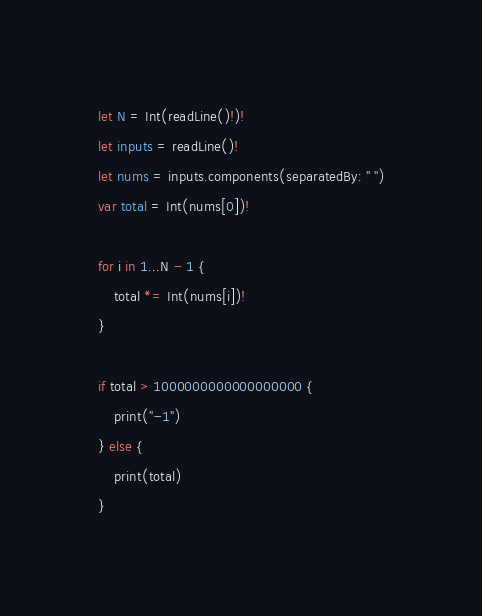<code> <loc_0><loc_0><loc_500><loc_500><_Swift_>let N = Int(readLine()!)!
let inputs = readLine()!
let nums = inputs.components(separatedBy: " ")
var total = Int(nums[0])!

for i in 1...N - 1 {
    total *= Int(nums[i])!
}

if total > 1000000000000000000 {
    print("-1")
} else {
    print(total)
}</code> 